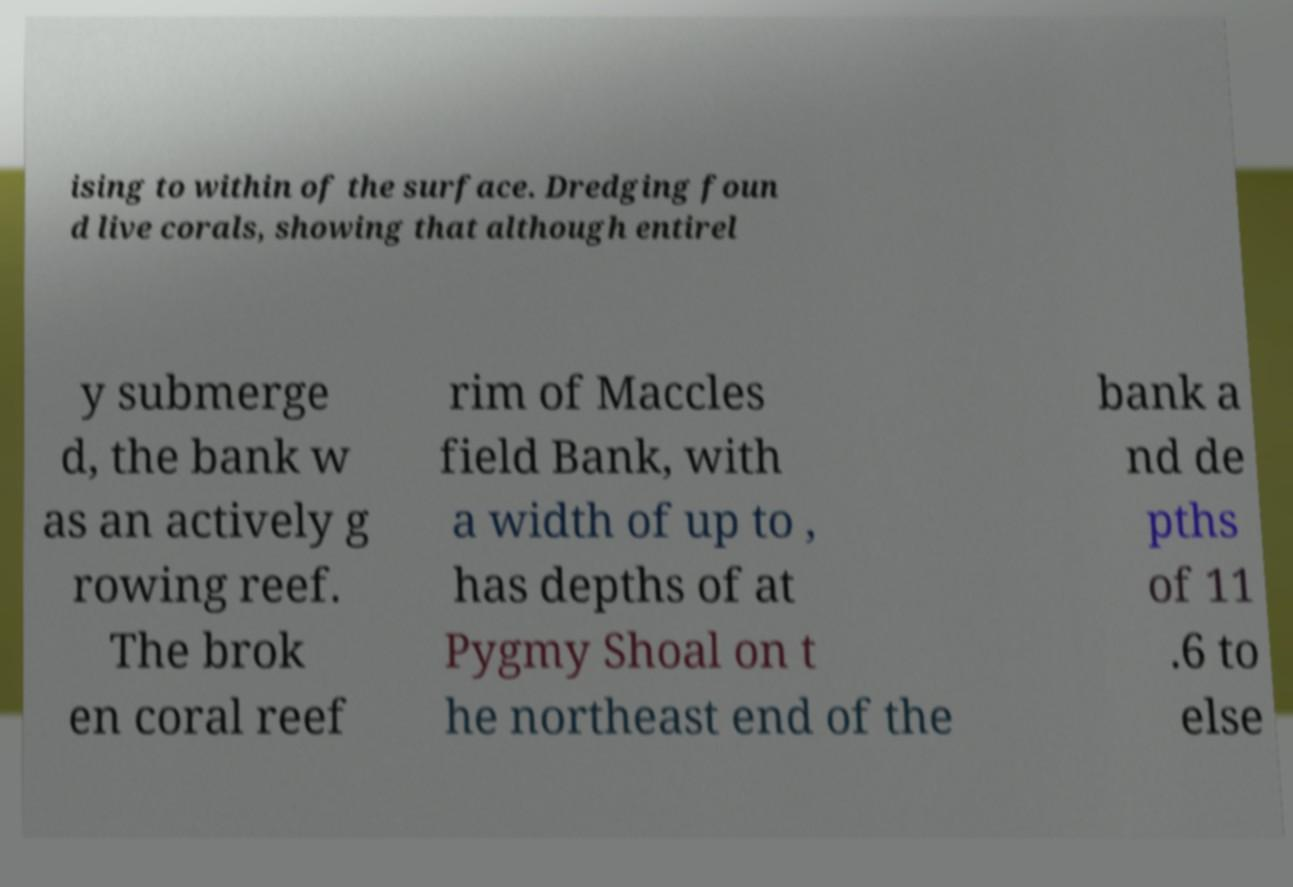Can you read and provide the text displayed in the image?This photo seems to have some interesting text. Can you extract and type it out for me? ising to within of the surface. Dredging foun d live corals, showing that although entirel y submerge d, the bank w as an actively g rowing reef. The brok en coral reef rim of Maccles field Bank, with a width of up to , has depths of at Pygmy Shoal on t he northeast end of the bank a nd de pths of 11 .6 to else 